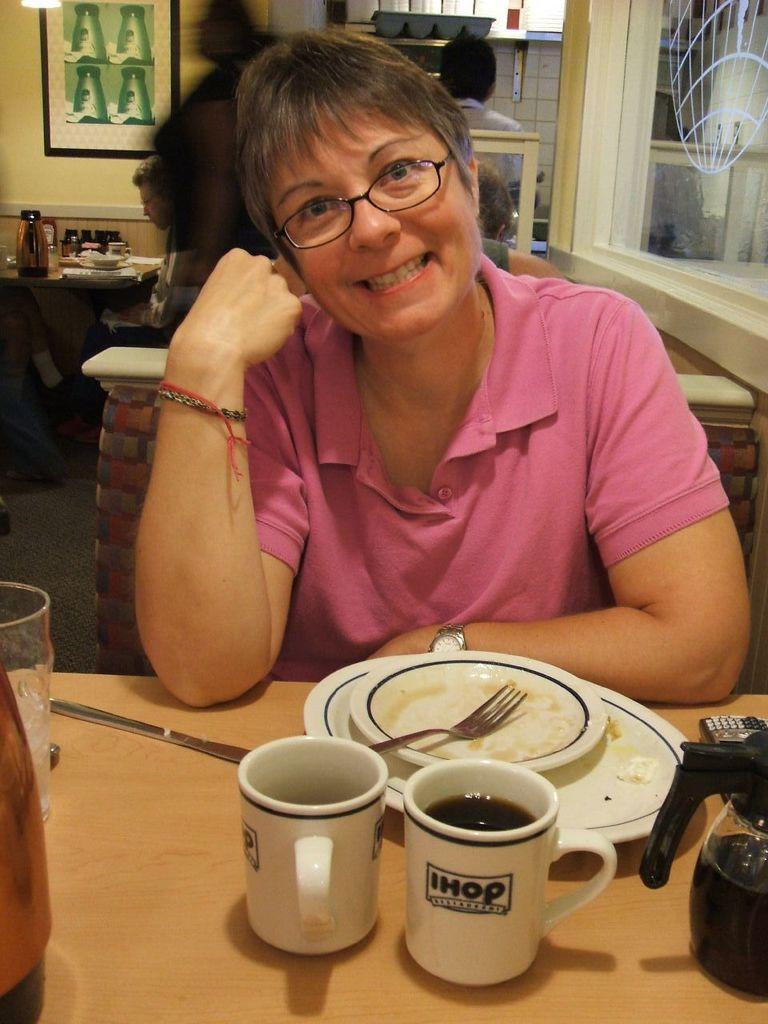How would you summarize this image in a sentence or two? This picture is clicked inside. In the foreground there is a wooden table on the top of which there is a glass, coffee mugs, plates, fork, knife and a glass jug and some other items are placed. In the center there is a person wearing pink color t-shirt, smiling and sitting on the chair. In the background we can see the group of persons and we can see a table on the top of which there are some objects and we can see a picture frame hanging on the wall and we can see many other objects. 